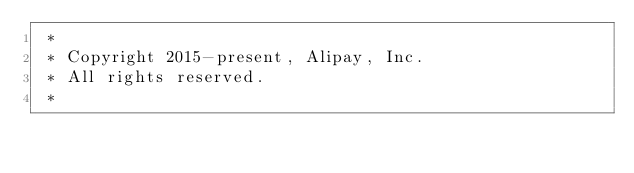Convert code to text. <code><loc_0><loc_0><loc_500><loc_500><_CSS_> * 
 * Copyright 2015-present, Alipay, Inc.
 * All rights reserved.
 *       </code> 